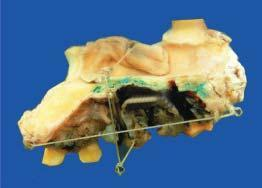does the hemimaxillectomy specimen show an elevated blackish ulcerated area with irregular outlines?
Answer the question using a single word or phrase. Yes 